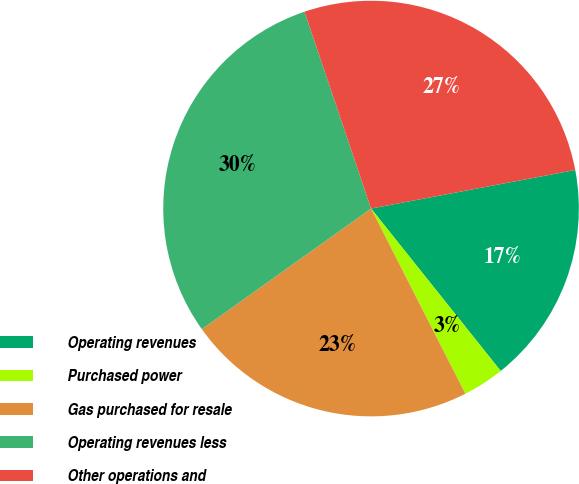<chart> <loc_0><loc_0><loc_500><loc_500><pie_chart><fcel>Operating revenues<fcel>Purchased power<fcel>Gas purchased for resale<fcel>Operating revenues less<fcel>Other operations and<nl><fcel>17.25%<fcel>3.23%<fcel>22.64%<fcel>29.67%<fcel>27.22%<nl></chart> 